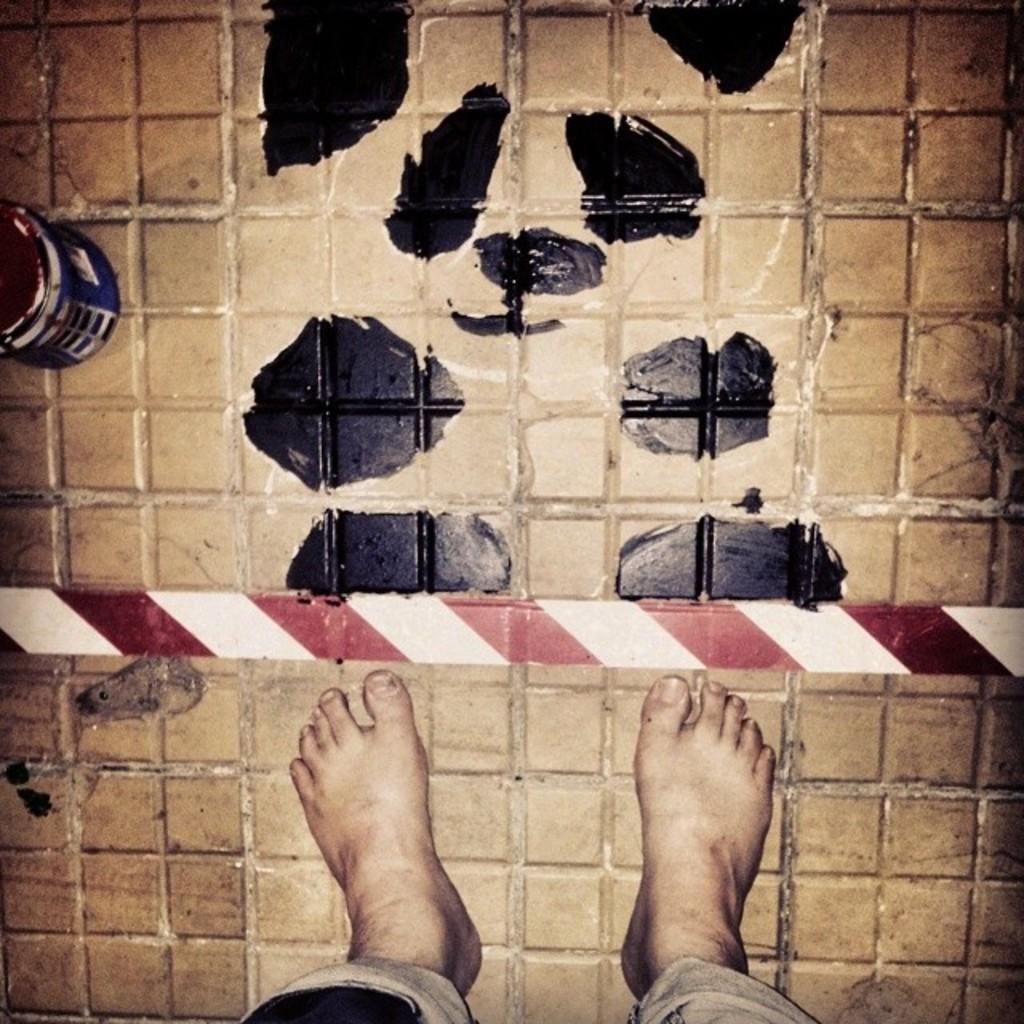Describe this image in one or two sentences. In this image I can see a person legs and I can see floor in brown and black color. 